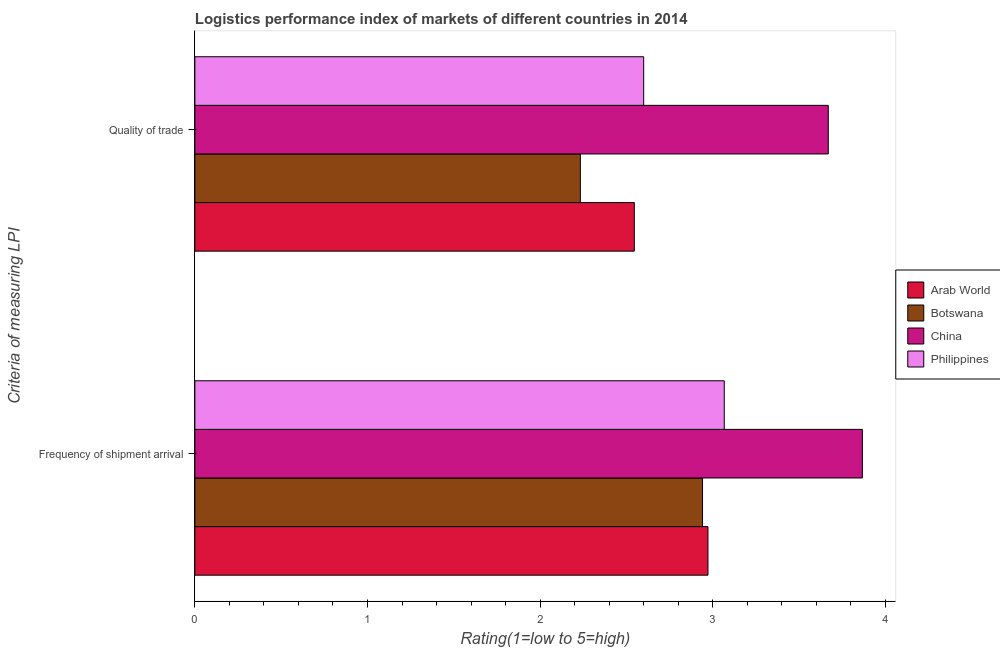How many different coloured bars are there?
Your answer should be compact. 4. Are the number of bars on each tick of the Y-axis equal?
Keep it short and to the point. Yes. How many bars are there on the 2nd tick from the bottom?
Give a very brief answer. 4. What is the label of the 2nd group of bars from the top?
Your response must be concise. Frequency of shipment arrival. What is the lpi quality of trade in Philippines?
Ensure brevity in your answer.  2.6. Across all countries, what is the maximum lpi of frequency of shipment arrival?
Provide a succinct answer. 3.87. Across all countries, what is the minimum lpi of frequency of shipment arrival?
Offer a very short reply. 2.94. In which country was the lpi of frequency of shipment arrival maximum?
Provide a short and direct response. China. In which country was the lpi of frequency of shipment arrival minimum?
Ensure brevity in your answer.  Botswana. What is the total lpi of frequency of shipment arrival in the graph?
Your answer should be very brief. 12.85. What is the difference between the lpi quality of trade in Philippines and that in China?
Keep it short and to the point. -1.07. What is the difference between the lpi of frequency of shipment arrival in Botswana and the lpi quality of trade in Philippines?
Keep it short and to the point. 0.34. What is the average lpi of frequency of shipment arrival per country?
Offer a very short reply. 3.21. What is the difference between the lpi quality of trade and lpi of frequency of shipment arrival in China?
Provide a succinct answer. -0.2. What is the ratio of the lpi quality of trade in Philippines to that in Botswana?
Give a very brief answer. 1.16. Is the lpi of frequency of shipment arrival in China less than that in Philippines?
Provide a succinct answer. No. In how many countries, is the lpi of frequency of shipment arrival greater than the average lpi of frequency of shipment arrival taken over all countries?
Offer a very short reply. 1. What does the 1st bar from the top in Frequency of shipment arrival represents?
Provide a short and direct response. Philippines. What does the 1st bar from the bottom in Frequency of shipment arrival represents?
Provide a succinct answer. Arab World. Are the values on the major ticks of X-axis written in scientific E-notation?
Give a very brief answer. No. Does the graph contain any zero values?
Offer a very short reply. No. Does the graph contain grids?
Your response must be concise. No. What is the title of the graph?
Provide a short and direct response. Logistics performance index of markets of different countries in 2014. What is the label or title of the X-axis?
Your answer should be compact. Rating(1=low to 5=high). What is the label or title of the Y-axis?
Offer a terse response. Criteria of measuring LPI. What is the Rating(1=low to 5=high) of Arab World in Frequency of shipment arrival?
Offer a terse response. 2.97. What is the Rating(1=low to 5=high) of Botswana in Frequency of shipment arrival?
Make the answer very short. 2.94. What is the Rating(1=low to 5=high) in China in Frequency of shipment arrival?
Keep it short and to the point. 3.87. What is the Rating(1=low to 5=high) in Philippines in Frequency of shipment arrival?
Provide a succinct answer. 3.07. What is the Rating(1=low to 5=high) in Arab World in Quality of trade?
Offer a very short reply. 2.55. What is the Rating(1=low to 5=high) in Botswana in Quality of trade?
Offer a terse response. 2.23. What is the Rating(1=low to 5=high) in China in Quality of trade?
Ensure brevity in your answer.  3.67. What is the Rating(1=low to 5=high) in Philippines in Quality of trade?
Ensure brevity in your answer.  2.6. Across all Criteria of measuring LPI, what is the maximum Rating(1=low to 5=high) in Arab World?
Your answer should be compact. 2.97. Across all Criteria of measuring LPI, what is the maximum Rating(1=low to 5=high) of Botswana?
Offer a very short reply. 2.94. Across all Criteria of measuring LPI, what is the maximum Rating(1=low to 5=high) of China?
Ensure brevity in your answer.  3.87. Across all Criteria of measuring LPI, what is the maximum Rating(1=low to 5=high) in Philippines?
Provide a short and direct response. 3.07. Across all Criteria of measuring LPI, what is the minimum Rating(1=low to 5=high) in Arab World?
Give a very brief answer. 2.55. Across all Criteria of measuring LPI, what is the minimum Rating(1=low to 5=high) in Botswana?
Keep it short and to the point. 2.23. Across all Criteria of measuring LPI, what is the minimum Rating(1=low to 5=high) of China?
Provide a short and direct response. 3.67. Across all Criteria of measuring LPI, what is the minimum Rating(1=low to 5=high) in Philippines?
Give a very brief answer. 2.6. What is the total Rating(1=low to 5=high) of Arab World in the graph?
Give a very brief answer. 5.52. What is the total Rating(1=low to 5=high) in Botswana in the graph?
Offer a terse response. 5.17. What is the total Rating(1=low to 5=high) in China in the graph?
Offer a terse response. 7.54. What is the total Rating(1=low to 5=high) in Philippines in the graph?
Offer a very short reply. 5.67. What is the difference between the Rating(1=low to 5=high) in Arab World in Frequency of shipment arrival and that in Quality of trade?
Your response must be concise. 0.43. What is the difference between the Rating(1=low to 5=high) in Botswana in Frequency of shipment arrival and that in Quality of trade?
Offer a very short reply. 0.71. What is the difference between the Rating(1=low to 5=high) in China in Frequency of shipment arrival and that in Quality of trade?
Provide a succinct answer. 0.2. What is the difference between the Rating(1=low to 5=high) of Philippines in Frequency of shipment arrival and that in Quality of trade?
Your answer should be compact. 0.47. What is the difference between the Rating(1=low to 5=high) of Arab World in Frequency of shipment arrival and the Rating(1=low to 5=high) of Botswana in Quality of trade?
Make the answer very short. 0.74. What is the difference between the Rating(1=low to 5=high) in Arab World in Frequency of shipment arrival and the Rating(1=low to 5=high) in China in Quality of trade?
Offer a terse response. -0.7. What is the difference between the Rating(1=low to 5=high) in Arab World in Frequency of shipment arrival and the Rating(1=low to 5=high) in Philippines in Quality of trade?
Your answer should be very brief. 0.37. What is the difference between the Rating(1=low to 5=high) of Botswana in Frequency of shipment arrival and the Rating(1=low to 5=high) of China in Quality of trade?
Your answer should be compact. -0.73. What is the difference between the Rating(1=low to 5=high) of Botswana in Frequency of shipment arrival and the Rating(1=low to 5=high) of Philippines in Quality of trade?
Keep it short and to the point. 0.34. What is the difference between the Rating(1=low to 5=high) of China in Frequency of shipment arrival and the Rating(1=low to 5=high) of Philippines in Quality of trade?
Keep it short and to the point. 1.27. What is the average Rating(1=low to 5=high) in Arab World per Criteria of measuring LPI?
Keep it short and to the point. 2.76. What is the average Rating(1=low to 5=high) of Botswana per Criteria of measuring LPI?
Your answer should be very brief. 2.59. What is the average Rating(1=low to 5=high) in China per Criteria of measuring LPI?
Your answer should be very brief. 3.77. What is the average Rating(1=low to 5=high) of Philippines per Criteria of measuring LPI?
Provide a succinct answer. 2.83. What is the difference between the Rating(1=low to 5=high) in Arab World and Rating(1=low to 5=high) in Botswana in Frequency of shipment arrival?
Provide a short and direct response. 0.03. What is the difference between the Rating(1=low to 5=high) in Arab World and Rating(1=low to 5=high) in China in Frequency of shipment arrival?
Make the answer very short. -0.89. What is the difference between the Rating(1=low to 5=high) of Arab World and Rating(1=low to 5=high) of Philippines in Frequency of shipment arrival?
Your response must be concise. -0.09. What is the difference between the Rating(1=low to 5=high) in Botswana and Rating(1=low to 5=high) in China in Frequency of shipment arrival?
Offer a very short reply. -0.93. What is the difference between the Rating(1=low to 5=high) in Botswana and Rating(1=low to 5=high) in Philippines in Frequency of shipment arrival?
Offer a terse response. -0.13. What is the difference between the Rating(1=low to 5=high) of China and Rating(1=low to 5=high) of Philippines in Frequency of shipment arrival?
Your response must be concise. 0.8. What is the difference between the Rating(1=low to 5=high) in Arab World and Rating(1=low to 5=high) in Botswana in Quality of trade?
Provide a succinct answer. 0.31. What is the difference between the Rating(1=low to 5=high) of Arab World and Rating(1=low to 5=high) of China in Quality of trade?
Offer a very short reply. -1.12. What is the difference between the Rating(1=low to 5=high) in Arab World and Rating(1=low to 5=high) in Philippines in Quality of trade?
Make the answer very short. -0.05. What is the difference between the Rating(1=low to 5=high) of Botswana and Rating(1=low to 5=high) of China in Quality of trade?
Offer a very short reply. -1.44. What is the difference between the Rating(1=low to 5=high) of Botswana and Rating(1=low to 5=high) of Philippines in Quality of trade?
Your answer should be very brief. -0.37. What is the difference between the Rating(1=low to 5=high) in China and Rating(1=low to 5=high) in Philippines in Quality of trade?
Give a very brief answer. 1.07. What is the ratio of the Rating(1=low to 5=high) in Arab World in Frequency of shipment arrival to that in Quality of trade?
Keep it short and to the point. 1.17. What is the ratio of the Rating(1=low to 5=high) of Botswana in Frequency of shipment arrival to that in Quality of trade?
Your answer should be compact. 1.32. What is the ratio of the Rating(1=low to 5=high) of China in Frequency of shipment arrival to that in Quality of trade?
Your answer should be very brief. 1.05. What is the ratio of the Rating(1=low to 5=high) in Philippines in Frequency of shipment arrival to that in Quality of trade?
Your answer should be compact. 1.18. What is the difference between the highest and the second highest Rating(1=low to 5=high) in Arab World?
Offer a terse response. 0.43. What is the difference between the highest and the second highest Rating(1=low to 5=high) in Botswana?
Make the answer very short. 0.71. What is the difference between the highest and the second highest Rating(1=low to 5=high) of China?
Offer a very short reply. 0.2. What is the difference between the highest and the second highest Rating(1=low to 5=high) in Philippines?
Your response must be concise. 0.47. What is the difference between the highest and the lowest Rating(1=low to 5=high) in Arab World?
Give a very brief answer. 0.43. What is the difference between the highest and the lowest Rating(1=low to 5=high) of Botswana?
Offer a terse response. 0.71. What is the difference between the highest and the lowest Rating(1=low to 5=high) of China?
Provide a short and direct response. 0.2. What is the difference between the highest and the lowest Rating(1=low to 5=high) of Philippines?
Keep it short and to the point. 0.47. 